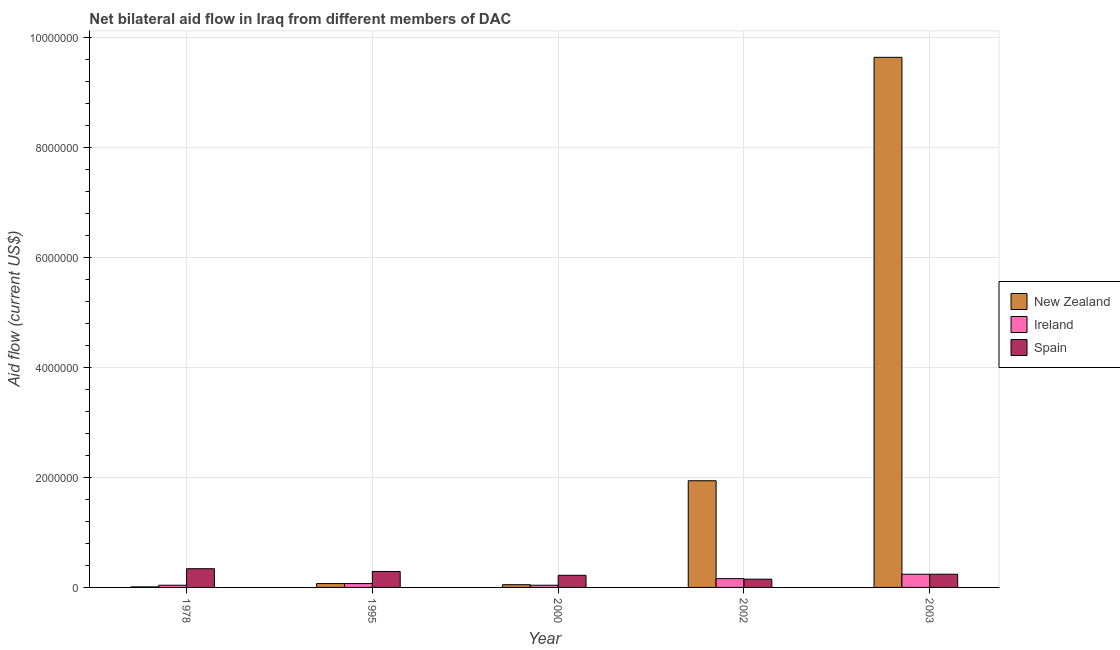How many groups of bars are there?
Your answer should be very brief. 5. Are the number of bars on each tick of the X-axis equal?
Provide a short and direct response. Yes. How many bars are there on the 2nd tick from the right?
Offer a very short reply. 3. What is the label of the 2nd group of bars from the left?
Your answer should be compact. 1995. What is the amount of aid provided by ireland in 1978?
Your answer should be compact. 4.00e+04. Across all years, what is the maximum amount of aid provided by new zealand?
Keep it short and to the point. 9.64e+06. Across all years, what is the minimum amount of aid provided by spain?
Offer a very short reply. 1.50e+05. In which year was the amount of aid provided by spain maximum?
Ensure brevity in your answer.  1978. In which year was the amount of aid provided by new zealand minimum?
Offer a terse response. 1978. What is the total amount of aid provided by ireland in the graph?
Ensure brevity in your answer.  5.50e+05. What is the difference between the amount of aid provided by spain in 2000 and that in 2003?
Make the answer very short. -2.00e+04. What is the difference between the amount of aid provided by ireland in 2000 and the amount of aid provided by new zealand in 1995?
Ensure brevity in your answer.  -3.00e+04. What is the average amount of aid provided by new zealand per year?
Your response must be concise. 2.34e+06. What is the ratio of the amount of aid provided by spain in 1978 to that in 2000?
Give a very brief answer. 1.55. What is the difference between the highest and the second highest amount of aid provided by new zealand?
Your answer should be very brief. 7.70e+06. What is the difference between the highest and the lowest amount of aid provided by ireland?
Make the answer very short. 2.00e+05. In how many years, is the amount of aid provided by spain greater than the average amount of aid provided by spain taken over all years?
Provide a short and direct response. 2. What does the 1st bar from the left in 2003 represents?
Your answer should be very brief. New Zealand. What does the 3rd bar from the right in 2002 represents?
Offer a very short reply. New Zealand. How many bars are there?
Provide a short and direct response. 15. How many years are there in the graph?
Offer a very short reply. 5. What is the difference between two consecutive major ticks on the Y-axis?
Your answer should be compact. 2.00e+06. Where does the legend appear in the graph?
Offer a terse response. Center right. How are the legend labels stacked?
Your response must be concise. Vertical. What is the title of the graph?
Offer a terse response. Net bilateral aid flow in Iraq from different members of DAC. Does "Nuclear sources" appear as one of the legend labels in the graph?
Provide a short and direct response. No. What is the label or title of the X-axis?
Keep it short and to the point. Year. What is the label or title of the Y-axis?
Make the answer very short. Aid flow (current US$). What is the Aid flow (current US$) in New Zealand in 1995?
Ensure brevity in your answer.  7.00e+04. What is the Aid flow (current US$) in Ireland in 1995?
Offer a very short reply. 7.00e+04. What is the Aid flow (current US$) of Ireland in 2000?
Offer a terse response. 4.00e+04. What is the Aid flow (current US$) of Spain in 2000?
Provide a short and direct response. 2.20e+05. What is the Aid flow (current US$) in New Zealand in 2002?
Give a very brief answer. 1.94e+06. What is the Aid flow (current US$) of Spain in 2002?
Offer a very short reply. 1.50e+05. What is the Aid flow (current US$) of New Zealand in 2003?
Your response must be concise. 9.64e+06. What is the Aid flow (current US$) in Spain in 2003?
Give a very brief answer. 2.40e+05. Across all years, what is the maximum Aid flow (current US$) in New Zealand?
Provide a short and direct response. 9.64e+06. Across all years, what is the maximum Aid flow (current US$) in Spain?
Make the answer very short. 3.40e+05. Across all years, what is the minimum Aid flow (current US$) of New Zealand?
Provide a succinct answer. 10000. What is the total Aid flow (current US$) in New Zealand in the graph?
Give a very brief answer. 1.17e+07. What is the total Aid flow (current US$) of Ireland in the graph?
Give a very brief answer. 5.50e+05. What is the total Aid flow (current US$) in Spain in the graph?
Offer a terse response. 1.24e+06. What is the difference between the Aid flow (current US$) of New Zealand in 1978 and that in 1995?
Provide a short and direct response. -6.00e+04. What is the difference between the Aid flow (current US$) in Ireland in 1978 and that in 1995?
Provide a short and direct response. -3.00e+04. What is the difference between the Aid flow (current US$) of Ireland in 1978 and that in 2000?
Keep it short and to the point. 0. What is the difference between the Aid flow (current US$) in New Zealand in 1978 and that in 2002?
Keep it short and to the point. -1.93e+06. What is the difference between the Aid flow (current US$) of Ireland in 1978 and that in 2002?
Provide a short and direct response. -1.20e+05. What is the difference between the Aid flow (current US$) of Spain in 1978 and that in 2002?
Ensure brevity in your answer.  1.90e+05. What is the difference between the Aid flow (current US$) in New Zealand in 1978 and that in 2003?
Offer a terse response. -9.63e+06. What is the difference between the Aid flow (current US$) of Spain in 1978 and that in 2003?
Keep it short and to the point. 1.00e+05. What is the difference between the Aid flow (current US$) in Ireland in 1995 and that in 2000?
Your response must be concise. 3.00e+04. What is the difference between the Aid flow (current US$) of New Zealand in 1995 and that in 2002?
Make the answer very short. -1.87e+06. What is the difference between the Aid flow (current US$) of Spain in 1995 and that in 2002?
Your answer should be very brief. 1.40e+05. What is the difference between the Aid flow (current US$) in New Zealand in 1995 and that in 2003?
Your answer should be very brief. -9.57e+06. What is the difference between the Aid flow (current US$) of Ireland in 1995 and that in 2003?
Your response must be concise. -1.70e+05. What is the difference between the Aid flow (current US$) in Spain in 1995 and that in 2003?
Your response must be concise. 5.00e+04. What is the difference between the Aid flow (current US$) of New Zealand in 2000 and that in 2002?
Provide a succinct answer. -1.89e+06. What is the difference between the Aid flow (current US$) of Spain in 2000 and that in 2002?
Your answer should be very brief. 7.00e+04. What is the difference between the Aid flow (current US$) of New Zealand in 2000 and that in 2003?
Give a very brief answer. -9.59e+06. What is the difference between the Aid flow (current US$) of Spain in 2000 and that in 2003?
Your answer should be very brief. -2.00e+04. What is the difference between the Aid flow (current US$) in New Zealand in 2002 and that in 2003?
Your response must be concise. -7.70e+06. What is the difference between the Aid flow (current US$) of New Zealand in 1978 and the Aid flow (current US$) of Ireland in 1995?
Ensure brevity in your answer.  -6.00e+04. What is the difference between the Aid flow (current US$) in New Zealand in 1978 and the Aid flow (current US$) in Spain in 1995?
Provide a short and direct response. -2.80e+05. What is the difference between the Aid flow (current US$) of New Zealand in 1978 and the Aid flow (current US$) of Ireland in 2000?
Your answer should be very brief. -3.00e+04. What is the difference between the Aid flow (current US$) in New Zealand in 1978 and the Aid flow (current US$) in Spain in 2000?
Provide a succinct answer. -2.10e+05. What is the difference between the Aid flow (current US$) in Ireland in 1978 and the Aid flow (current US$) in Spain in 2002?
Provide a short and direct response. -1.10e+05. What is the difference between the Aid flow (current US$) in New Zealand in 1978 and the Aid flow (current US$) in Ireland in 2003?
Provide a succinct answer. -2.30e+05. What is the difference between the Aid flow (current US$) in Ireland in 1978 and the Aid flow (current US$) in Spain in 2003?
Your answer should be very brief. -2.00e+05. What is the difference between the Aid flow (current US$) in New Zealand in 1995 and the Aid flow (current US$) in Ireland in 2002?
Offer a very short reply. -9.00e+04. What is the difference between the Aid flow (current US$) in New Zealand in 1995 and the Aid flow (current US$) in Spain in 2002?
Your answer should be compact. -8.00e+04. What is the difference between the Aid flow (current US$) of Ireland in 1995 and the Aid flow (current US$) of Spain in 2002?
Your answer should be very brief. -8.00e+04. What is the difference between the Aid flow (current US$) of New Zealand in 1995 and the Aid flow (current US$) of Spain in 2003?
Keep it short and to the point. -1.70e+05. What is the difference between the Aid flow (current US$) in Ireland in 1995 and the Aid flow (current US$) in Spain in 2003?
Provide a succinct answer. -1.70e+05. What is the difference between the Aid flow (current US$) of New Zealand in 2000 and the Aid flow (current US$) of Ireland in 2002?
Keep it short and to the point. -1.10e+05. What is the difference between the Aid flow (current US$) in Ireland in 2000 and the Aid flow (current US$) in Spain in 2002?
Your answer should be compact. -1.10e+05. What is the difference between the Aid flow (current US$) in New Zealand in 2002 and the Aid flow (current US$) in Ireland in 2003?
Your response must be concise. 1.70e+06. What is the difference between the Aid flow (current US$) of New Zealand in 2002 and the Aid flow (current US$) of Spain in 2003?
Ensure brevity in your answer.  1.70e+06. What is the average Aid flow (current US$) of New Zealand per year?
Ensure brevity in your answer.  2.34e+06. What is the average Aid flow (current US$) of Spain per year?
Offer a very short reply. 2.48e+05. In the year 1978, what is the difference between the Aid flow (current US$) in New Zealand and Aid flow (current US$) in Spain?
Give a very brief answer. -3.30e+05. In the year 1995, what is the difference between the Aid flow (current US$) in Ireland and Aid flow (current US$) in Spain?
Your answer should be compact. -2.20e+05. In the year 2000, what is the difference between the Aid flow (current US$) of New Zealand and Aid flow (current US$) of Spain?
Your answer should be very brief. -1.70e+05. In the year 2000, what is the difference between the Aid flow (current US$) of Ireland and Aid flow (current US$) of Spain?
Your response must be concise. -1.80e+05. In the year 2002, what is the difference between the Aid flow (current US$) of New Zealand and Aid flow (current US$) of Ireland?
Give a very brief answer. 1.78e+06. In the year 2002, what is the difference between the Aid flow (current US$) of New Zealand and Aid flow (current US$) of Spain?
Offer a terse response. 1.79e+06. In the year 2003, what is the difference between the Aid flow (current US$) of New Zealand and Aid flow (current US$) of Ireland?
Your answer should be very brief. 9.40e+06. In the year 2003, what is the difference between the Aid flow (current US$) in New Zealand and Aid flow (current US$) in Spain?
Make the answer very short. 9.40e+06. What is the ratio of the Aid flow (current US$) in New Zealand in 1978 to that in 1995?
Your answer should be very brief. 0.14. What is the ratio of the Aid flow (current US$) in Ireland in 1978 to that in 1995?
Your answer should be very brief. 0.57. What is the ratio of the Aid flow (current US$) in Spain in 1978 to that in 1995?
Give a very brief answer. 1.17. What is the ratio of the Aid flow (current US$) in Ireland in 1978 to that in 2000?
Make the answer very short. 1. What is the ratio of the Aid flow (current US$) of Spain in 1978 to that in 2000?
Keep it short and to the point. 1.55. What is the ratio of the Aid flow (current US$) of New Zealand in 1978 to that in 2002?
Ensure brevity in your answer.  0.01. What is the ratio of the Aid flow (current US$) of Spain in 1978 to that in 2002?
Your response must be concise. 2.27. What is the ratio of the Aid flow (current US$) of New Zealand in 1978 to that in 2003?
Your response must be concise. 0. What is the ratio of the Aid flow (current US$) in Spain in 1978 to that in 2003?
Give a very brief answer. 1.42. What is the ratio of the Aid flow (current US$) in New Zealand in 1995 to that in 2000?
Make the answer very short. 1.4. What is the ratio of the Aid flow (current US$) of Ireland in 1995 to that in 2000?
Provide a succinct answer. 1.75. What is the ratio of the Aid flow (current US$) in Spain in 1995 to that in 2000?
Provide a short and direct response. 1.32. What is the ratio of the Aid flow (current US$) of New Zealand in 1995 to that in 2002?
Offer a terse response. 0.04. What is the ratio of the Aid flow (current US$) of Ireland in 1995 to that in 2002?
Provide a short and direct response. 0.44. What is the ratio of the Aid flow (current US$) in Spain in 1995 to that in 2002?
Provide a succinct answer. 1.93. What is the ratio of the Aid flow (current US$) of New Zealand in 1995 to that in 2003?
Make the answer very short. 0.01. What is the ratio of the Aid flow (current US$) in Ireland in 1995 to that in 2003?
Offer a very short reply. 0.29. What is the ratio of the Aid flow (current US$) of Spain in 1995 to that in 2003?
Your response must be concise. 1.21. What is the ratio of the Aid flow (current US$) in New Zealand in 2000 to that in 2002?
Your response must be concise. 0.03. What is the ratio of the Aid flow (current US$) in Spain in 2000 to that in 2002?
Offer a very short reply. 1.47. What is the ratio of the Aid flow (current US$) in New Zealand in 2000 to that in 2003?
Provide a short and direct response. 0.01. What is the ratio of the Aid flow (current US$) in Spain in 2000 to that in 2003?
Keep it short and to the point. 0.92. What is the ratio of the Aid flow (current US$) in New Zealand in 2002 to that in 2003?
Give a very brief answer. 0.2. What is the ratio of the Aid flow (current US$) in Ireland in 2002 to that in 2003?
Ensure brevity in your answer.  0.67. What is the difference between the highest and the second highest Aid flow (current US$) of New Zealand?
Offer a terse response. 7.70e+06. What is the difference between the highest and the second highest Aid flow (current US$) of Spain?
Make the answer very short. 5.00e+04. What is the difference between the highest and the lowest Aid flow (current US$) of New Zealand?
Ensure brevity in your answer.  9.63e+06. What is the difference between the highest and the lowest Aid flow (current US$) in Ireland?
Your response must be concise. 2.00e+05. 